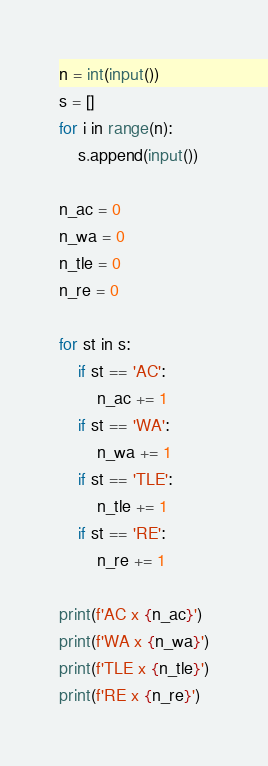Convert code to text. <code><loc_0><loc_0><loc_500><loc_500><_Python_>n = int(input())
s = []
for i in range(n):
    s.append(input())

n_ac = 0
n_wa = 0
n_tle = 0
n_re = 0

for st in s:
    if st == 'AC':
        n_ac += 1
    if st == 'WA':
        n_wa += 1
    if st == 'TLE':
        n_tle += 1
    if st == 'RE':
        n_re += 1

print(f'AC x {n_ac}')
print(f'WA x {n_wa}')
print(f'TLE x {n_tle}')
print(f'RE x {n_re}')
</code> 